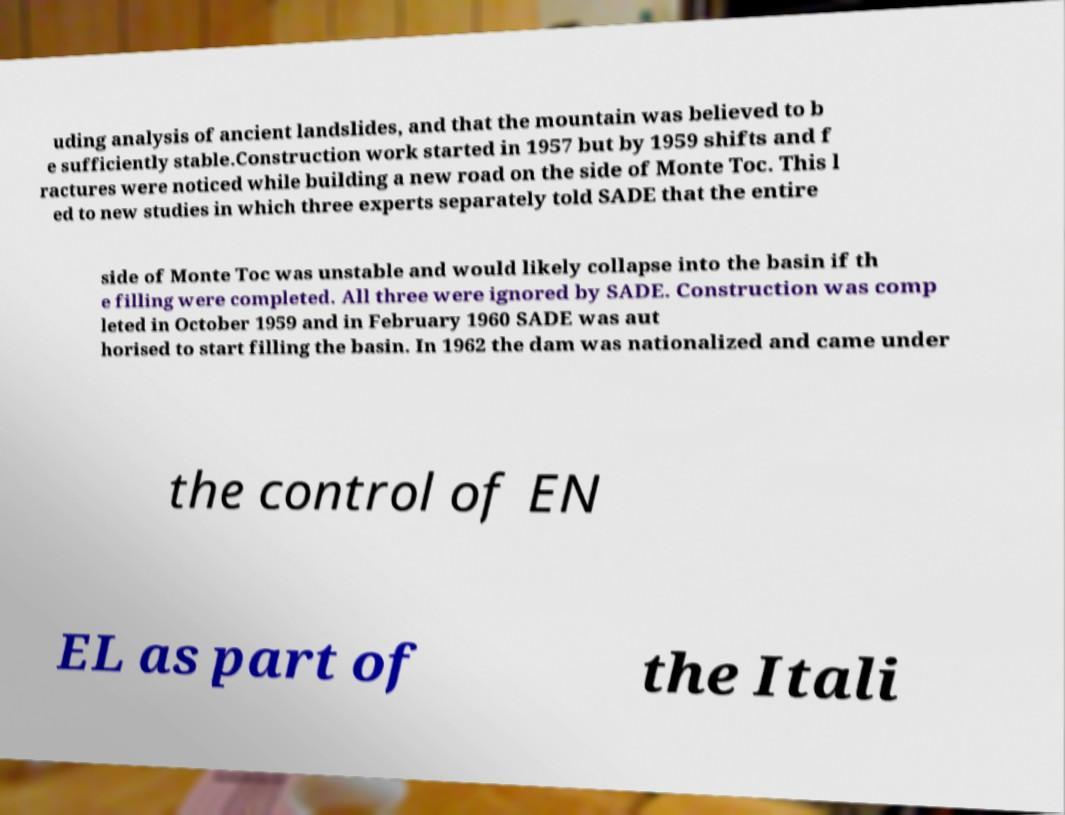There's text embedded in this image that I need extracted. Can you transcribe it verbatim? uding analysis of ancient landslides, and that the mountain was believed to b e sufficiently stable.Construction work started in 1957 but by 1959 shifts and f ractures were noticed while building a new road on the side of Monte Toc. This l ed to new studies in which three experts separately told SADE that the entire side of Monte Toc was unstable and would likely collapse into the basin if th e filling were completed. All three were ignored by SADE. Construction was comp leted in October 1959 and in February 1960 SADE was aut horised to start filling the basin. In 1962 the dam was nationalized and came under the control of EN EL as part of the Itali 